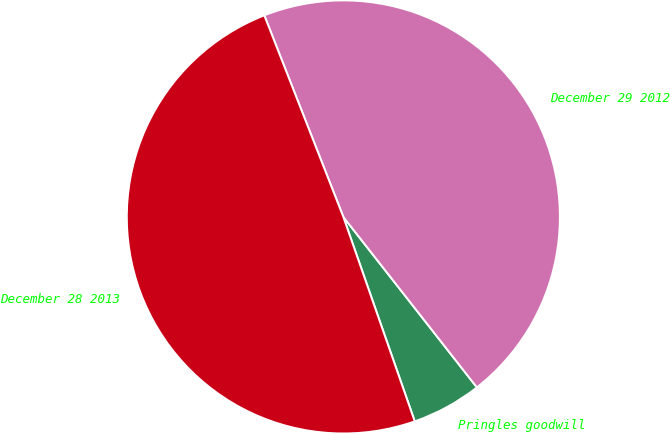Convert chart to OTSL. <chart><loc_0><loc_0><loc_500><loc_500><pie_chart><fcel>Pringles goodwill<fcel>December 29 2012<fcel>December 28 2013<nl><fcel>5.23%<fcel>45.37%<fcel>49.4%<nl></chart> 